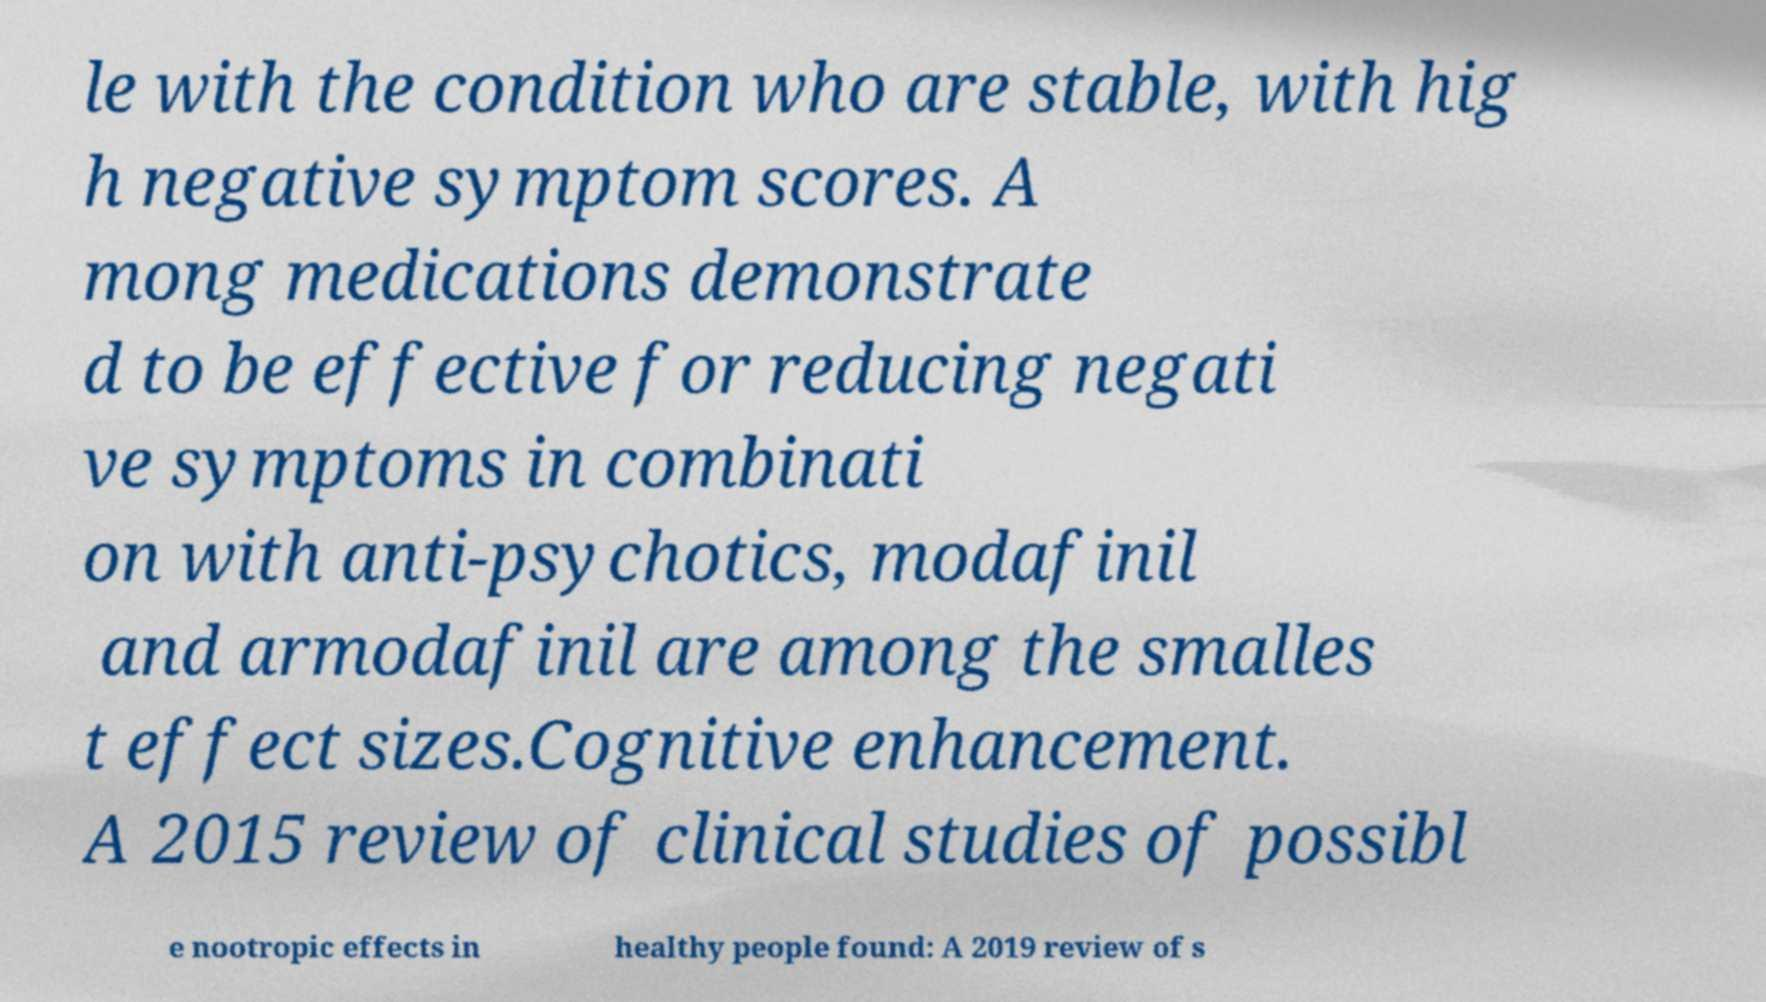For documentation purposes, I need the text within this image transcribed. Could you provide that? le with the condition who are stable, with hig h negative symptom scores. A mong medications demonstrate d to be effective for reducing negati ve symptoms in combinati on with anti-psychotics, modafinil and armodafinil are among the smalles t effect sizes.Cognitive enhancement. A 2015 review of clinical studies of possibl e nootropic effects in healthy people found: A 2019 review of s 